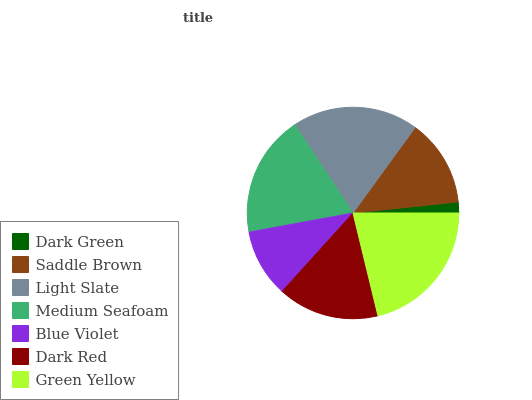Is Dark Green the minimum?
Answer yes or no. Yes. Is Green Yellow the maximum?
Answer yes or no. Yes. Is Saddle Brown the minimum?
Answer yes or no. No. Is Saddle Brown the maximum?
Answer yes or no. No. Is Saddle Brown greater than Dark Green?
Answer yes or no. Yes. Is Dark Green less than Saddle Brown?
Answer yes or no. Yes. Is Dark Green greater than Saddle Brown?
Answer yes or no. No. Is Saddle Brown less than Dark Green?
Answer yes or no. No. Is Dark Red the high median?
Answer yes or no. Yes. Is Dark Red the low median?
Answer yes or no. Yes. Is Blue Violet the high median?
Answer yes or no. No. Is Dark Green the low median?
Answer yes or no. No. 